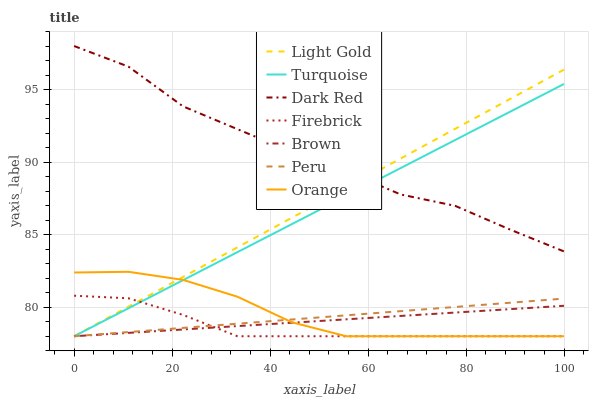Does Firebrick have the minimum area under the curve?
Answer yes or no. Yes. Does Dark Red have the maximum area under the curve?
Answer yes or no. Yes. Does Turquoise have the minimum area under the curve?
Answer yes or no. No. Does Turquoise have the maximum area under the curve?
Answer yes or no. No. Is Peru the smoothest?
Answer yes or no. Yes. Is Dark Red the roughest?
Answer yes or no. Yes. Is Turquoise the smoothest?
Answer yes or no. No. Is Turquoise the roughest?
Answer yes or no. No. Does Brown have the lowest value?
Answer yes or no. Yes. Does Dark Red have the lowest value?
Answer yes or no. No. Does Dark Red have the highest value?
Answer yes or no. Yes. Does Turquoise have the highest value?
Answer yes or no. No. Is Peru less than Dark Red?
Answer yes or no. Yes. Is Dark Red greater than Peru?
Answer yes or no. Yes. Does Firebrick intersect Peru?
Answer yes or no. Yes. Is Firebrick less than Peru?
Answer yes or no. No. Is Firebrick greater than Peru?
Answer yes or no. No. Does Peru intersect Dark Red?
Answer yes or no. No. 